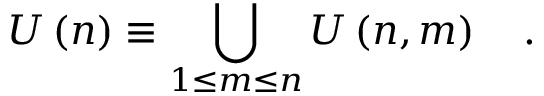<formula> <loc_0><loc_0><loc_500><loc_500>U \left ( n \right ) \equiv \bigcup _ { 1 \leq m \leq n } U \left ( n , m \right ) \quad .</formula> 